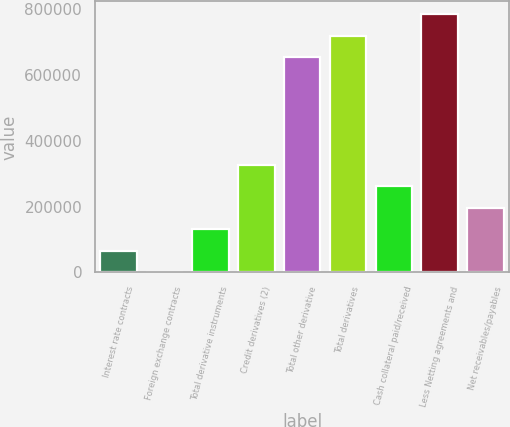Convert chart. <chart><loc_0><loc_0><loc_500><loc_500><bar_chart><fcel>Interest rate contracts<fcel>Foreign exchange contracts<fcel>Total derivative instruments<fcel>Credit derivatives (2)<fcel>Total other derivative<fcel>Total derivatives<fcel>Cash collateral paid/received<fcel>Less Netting agreements and<fcel>Net receivables/payables<nl><fcel>65827<fcel>357<fcel>131297<fcel>327707<fcel>653744<fcel>719214<fcel>262237<fcel>784684<fcel>196767<nl></chart> 